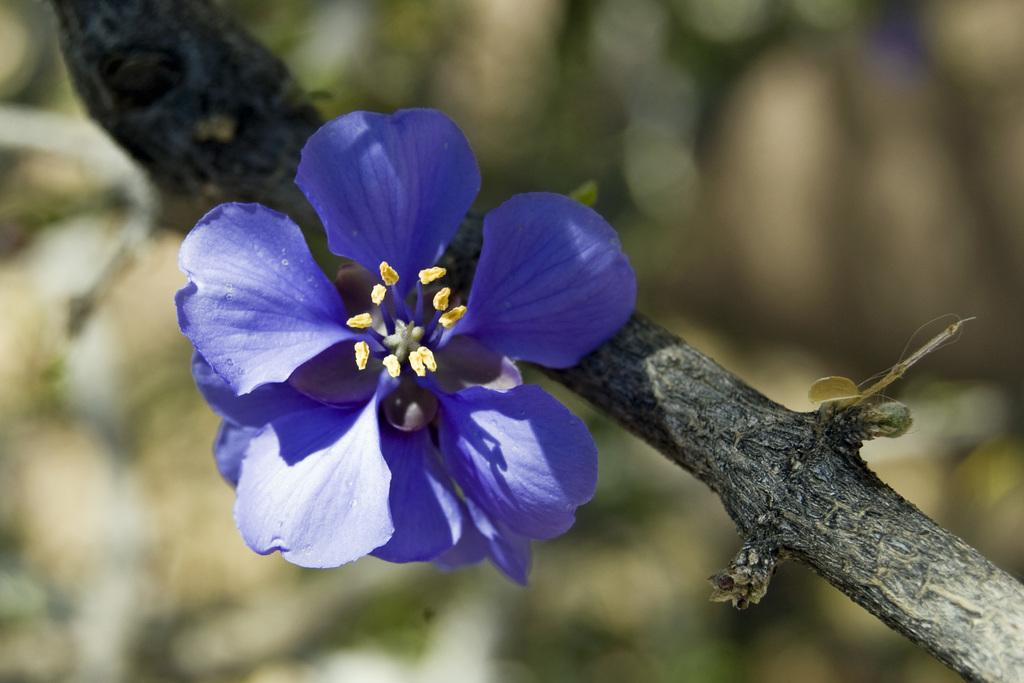What type of flower is in the image? There is a blue flower in the image. What are the reproductive parts of the flower? The flower has a stigma and pollen grains. What can be seen in the background of the image? There is a tree stem in the background of the image. Can you see a glass of water next to the flower in the image? There is no glass of water present in the image. Is there a horse grazing near the tree stem in the background? There is no horse present in the image. 